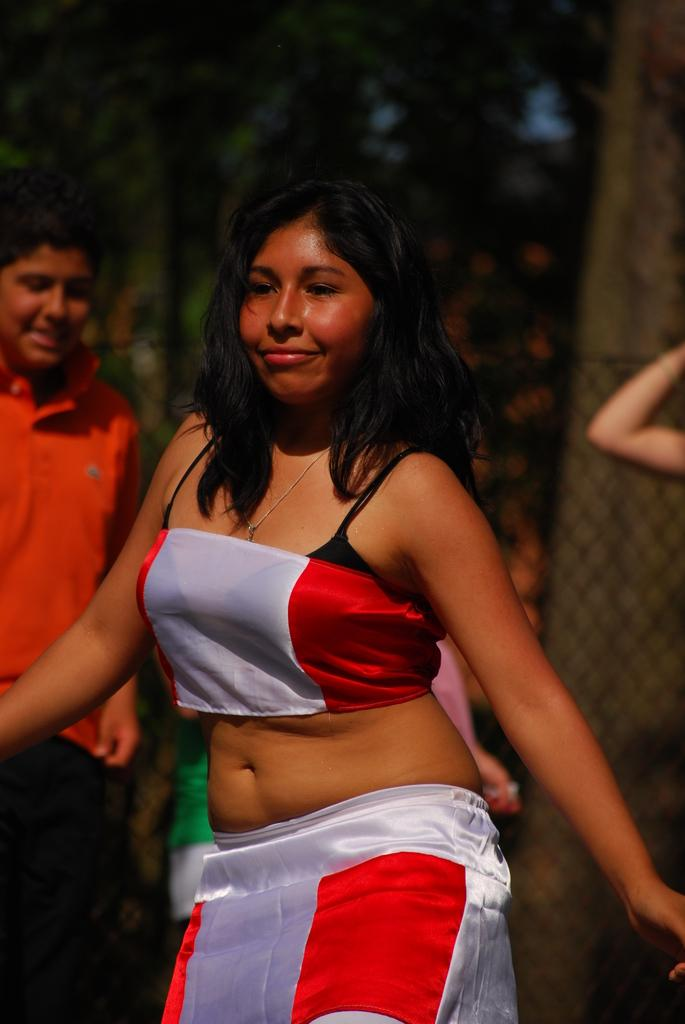What is the main subject of the image? There is a lady dancing in the middle of the image. Can you describe the surroundings of the lady? There are other people in the background of the image. How would you describe the background of the image? The background is blurry. How many times does the lady roll her neck while dancing in the image? There is no indication in the image that the lady is rolling her neck while dancing. 